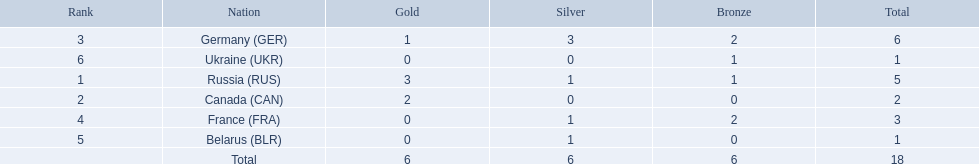Which countries competed in the 1995 biathlon? Russia (RUS), Canada (CAN), Germany (GER), France (FRA), Belarus (BLR), Ukraine (UKR). Can you give me this table as a dict? {'header': ['Rank', 'Nation', 'Gold', 'Silver', 'Bronze', 'Total'], 'rows': [['3', 'Germany\xa0(GER)', '1', '3', '2', '6'], ['6', 'Ukraine\xa0(UKR)', '0', '0', '1', '1'], ['1', 'Russia\xa0(RUS)', '3', '1', '1', '5'], ['2', 'Canada\xa0(CAN)', '2', '0', '0', '2'], ['4', 'France\xa0(FRA)', '0', '1', '2', '3'], ['5', 'Belarus\xa0(BLR)', '0', '1', '0', '1'], ['', 'Total', '6', '6', '6', '18']]} How many medals in total did they win? 5, 2, 6, 3, 1, 1. And which country had the most? Germany (GER). 